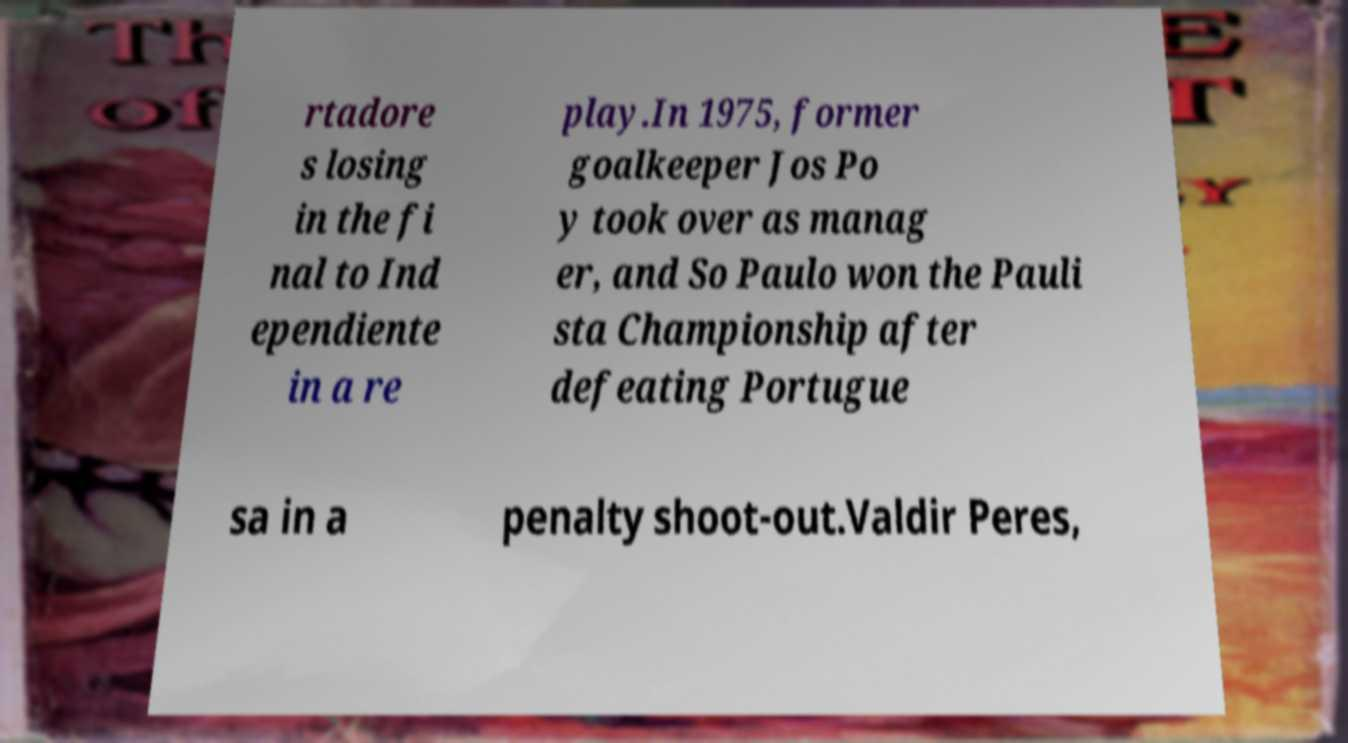Please read and relay the text visible in this image. What does it say? rtadore s losing in the fi nal to Ind ependiente in a re play.In 1975, former goalkeeper Jos Po y took over as manag er, and So Paulo won the Pauli sta Championship after defeating Portugue sa in a penalty shoot-out.Valdir Peres, 